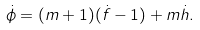<formula> <loc_0><loc_0><loc_500><loc_500>\dot { \phi } = ( m + 1 ) ( \dot { f } - 1 ) + m \dot { h } .</formula> 